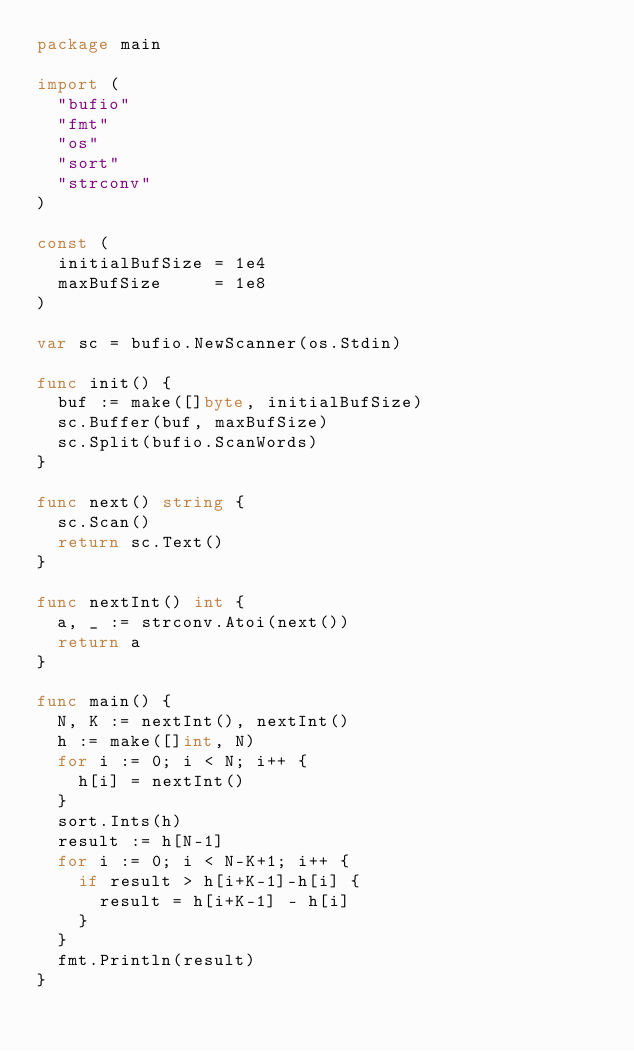Convert code to text. <code><loc_0><loc_0><loc_500><loc_500><_Go_>package main

import (
	"bufio"
	"fmt"
	"os"
	"sort"
	"strconv"
)

const (
	initialBufSize = 1e4
	maxBufSize     = 1e8
)

var sc = bufio.NewScanner(os.Stdin)

func init() {
	buf := make([]byte, initialBufSize)
	sc.Buffer(buf, maxBufSize)
	sc.Split(bufio.ScanWords)
}

func next() string {
	sc.Scan()
	return sc.Text()
}

func nextInt() int {
	a, _ := strconv.Atoi(next())
	return a
}

func main() {
	N, K := nextInt(), nextInt()
	h := make([]int, N)
	for i := 0; i < N; i++ {
		h[i] = nextInt()
	}
	sort.Ints(h)
	result := h[N-1]
	for i := 0; i < N-K+1; i++ {
		if result > h[i+K-1]-h[i] {
			result = h[i+K-1] - h[i]
		}
	}
	fmt.Println(result)
}
</code> 